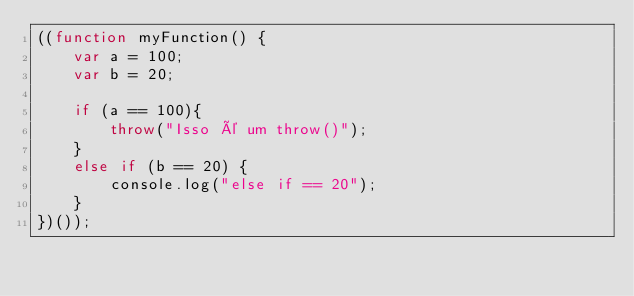<code> <loc_0><loc_0><loc_500><loc_500><_JavaScript_>((function myFunction() {
    var a = 100;
    var b = 20;

    if (a == 100){
        throw("Isso é um throw()");
    }
    else if (b == 20) {
        console.log("else if == 20");
    }
})());
</code> 